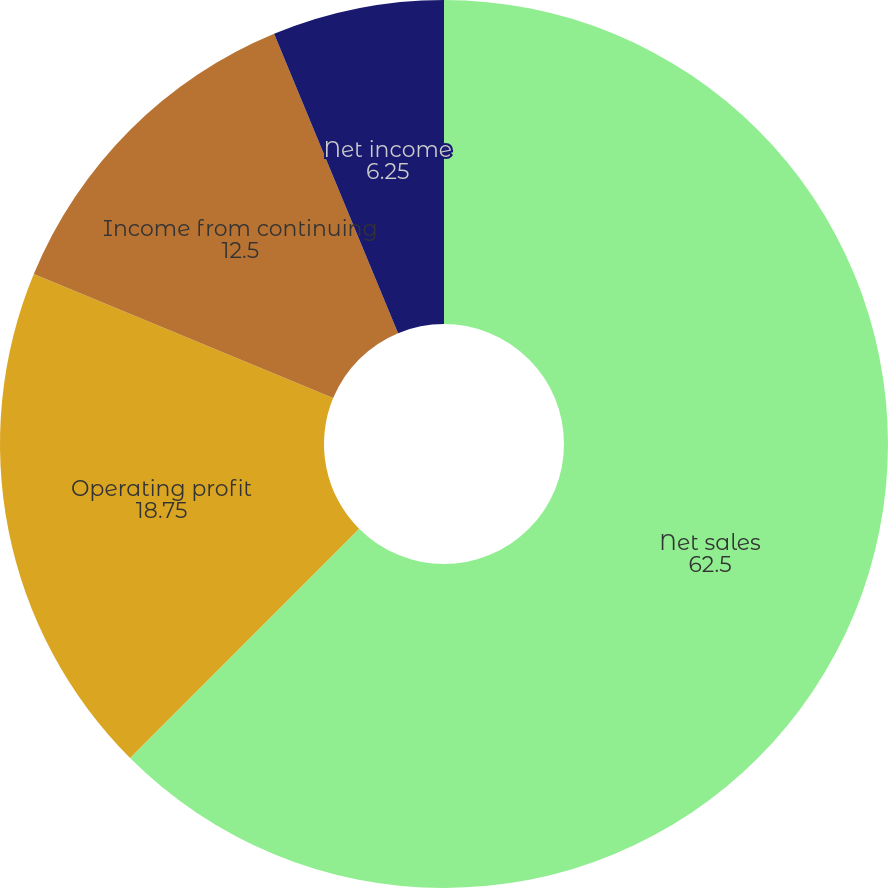Convert chart. <chart><loc_0><loc_0><loc_500><loc_500><pie_chart><fcel>Net sales<fcel>Operating profit<fcel>Income from continuing<fcel>Net income<fcel>Continuing operations<nl><fcel>62.5%<fcel>18.75%<fcel>12.5%<fcel>6.25%<fcel>0.0%<nl></chart> 